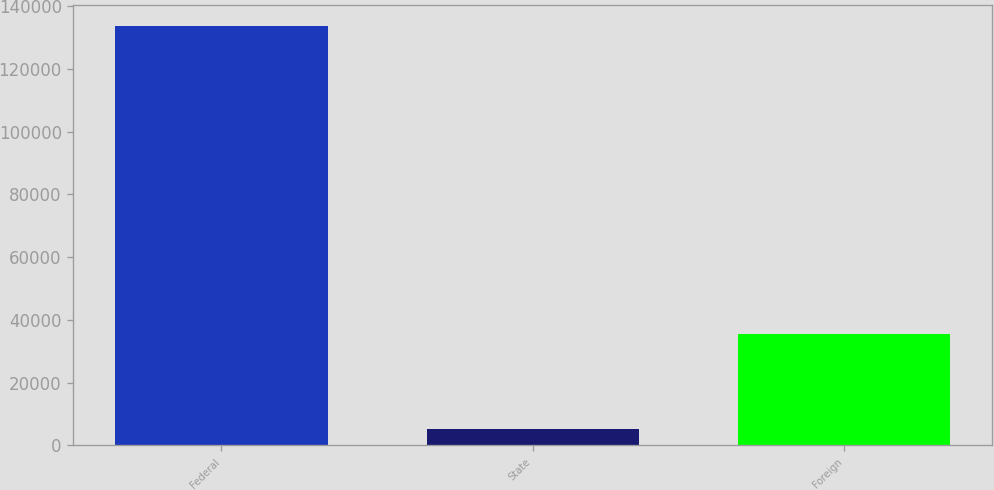<chart> <loc_0><loc_0><loc_500><loc_500><bar_chart><fcel>Federal<fcel>State<fcel>Foreign<nl><fcel>133621<fcel>5213<fcel>35444<nl></chart> 